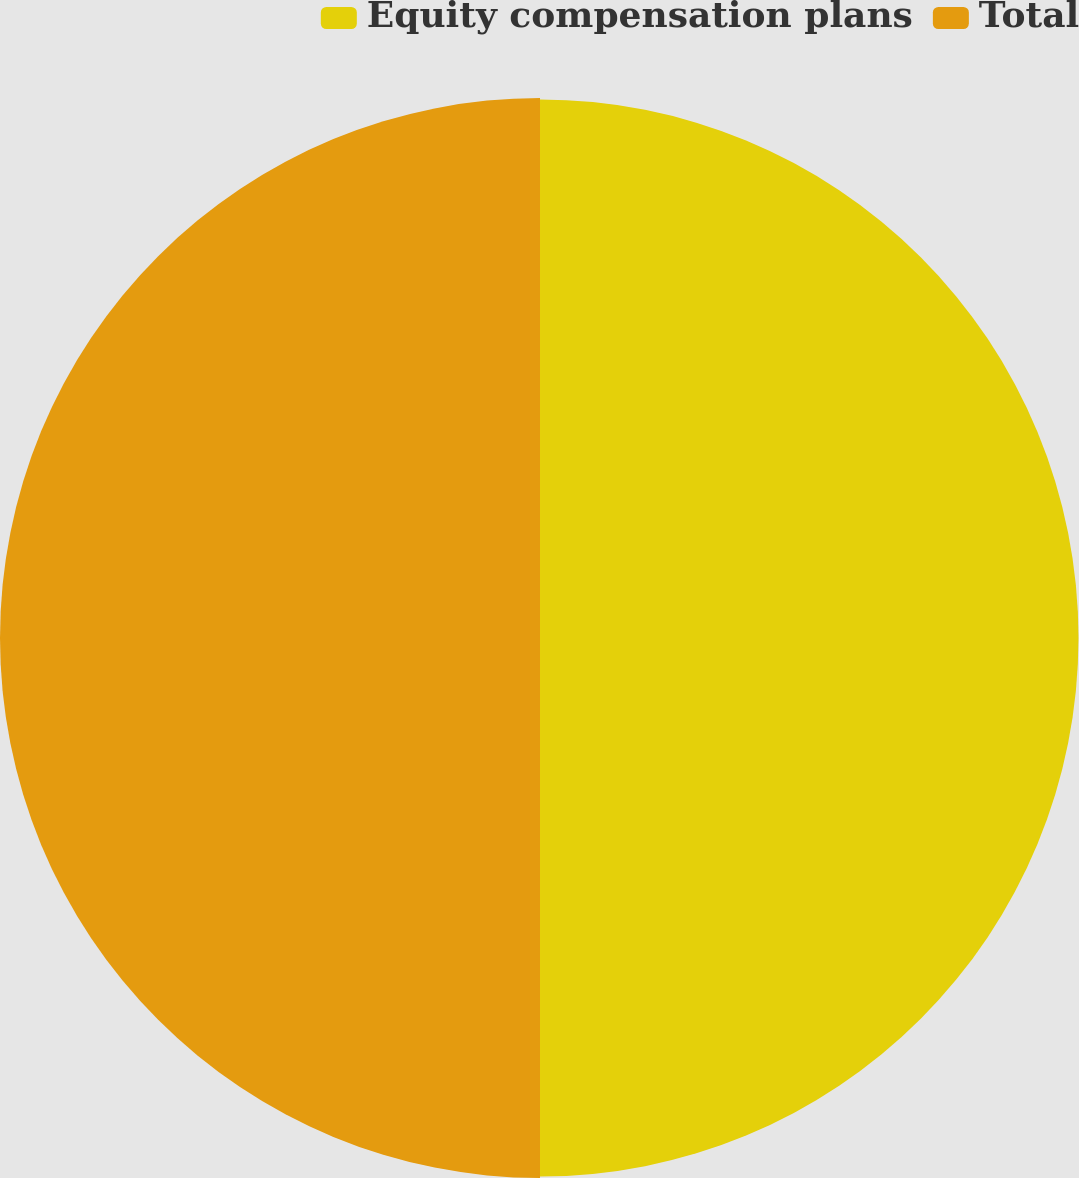Convert chart to OTSL. <chart><loc_0><loc_0><loc_500><loc_500><pie_chart><fcel>Equity compensation plans<fcel>Total<nl><fcel>49.93%<fcel>50.07%<nl></chart> 